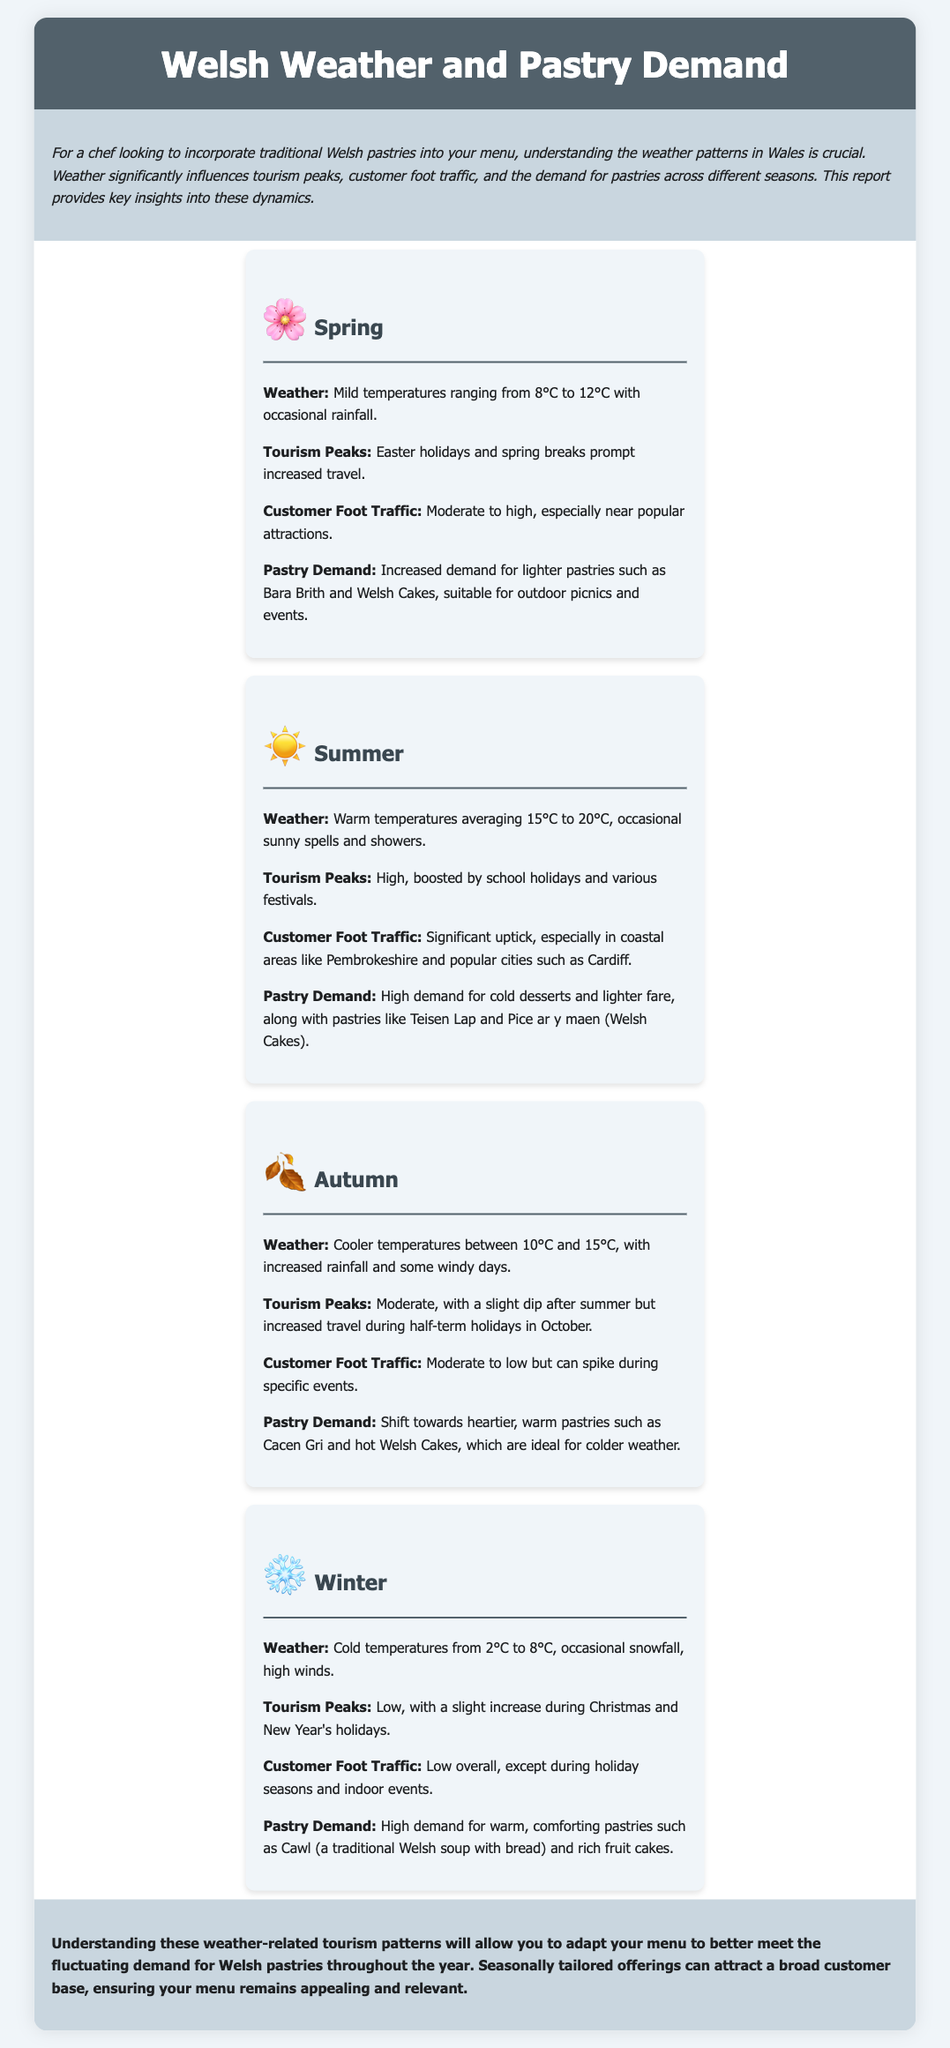What is the average temperature in summer? The average temperature in summer ranges from 15°C to 20°C.
Answer: 15°C to 20°C What pastries have increased demand in spring? Increased demand for lighter pastries such as Bara Brith and Welsh Cakes are noted.
Answer: Bara Brith and Welsh Cakes When is the peak tourism season for autumn? The peak tourism season for autumn is during half-term holidays in October.
Answer: Half-term holidays in October What weather is typical in winter? Cold temperatures from 2°C to 8°C are common in winter.
Answer: 2°C to 8°C What type of pastries are popular in winter? Popular pastries in winter include warm, comforting options like Cawl and rich fruit cakes.
Answer: Cawl and rich fruit cakes How does customer foot traffic change in summer? Customer foot traffic in summer sees a significant uptick, especially in coastal areas.
Answer: Significant uptick Which season has the lowest customer foot traffic? Winter is noted for having low overall customer foot traffic.
Answer: Winter What is the impact of Easter holidays on tourism? Easter holidays prompt increased travel during spring.
Answer: Increased travel during spring What pastries are in demand during autumn? In autumn, there is a demand for heartier, warm pastries such as Cacen Gri and hot Welsh Cakes.
Answer: Cacen Gri and hot Welsh Cakes 